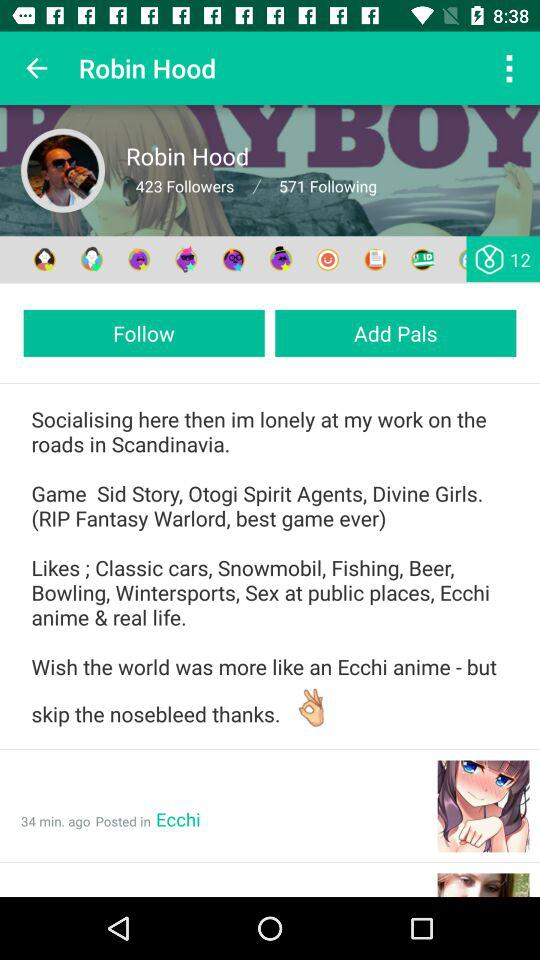How many followers does Robin Hood have?
Answer the question using a single word or phrase. 423 